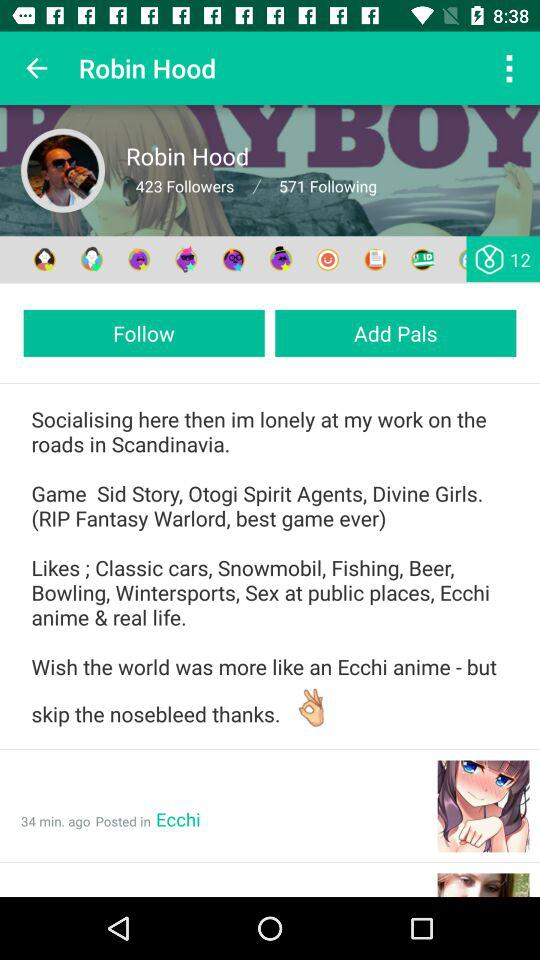How many followers does Robin Hood have?
Answer the question using a single word or phrase. 423 